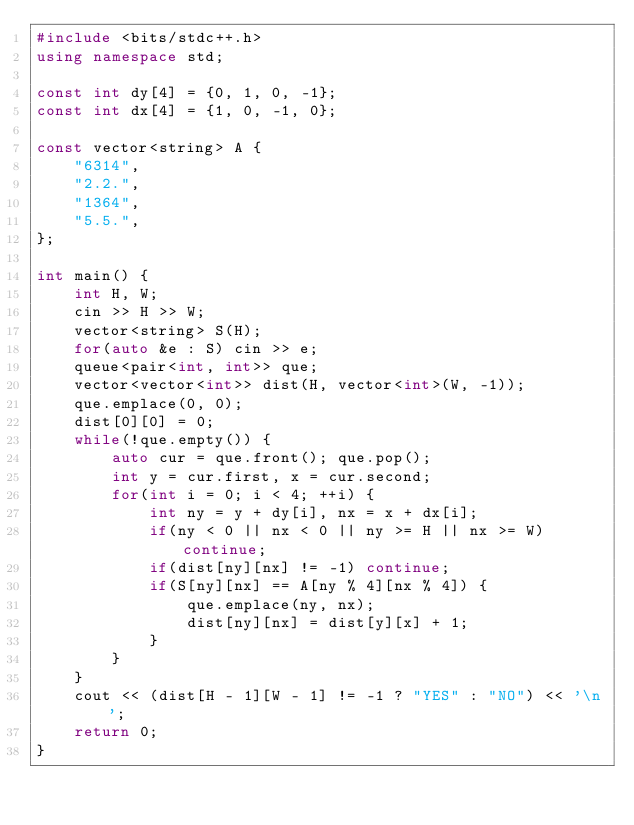<code> <loc_0><loc_0><loc_500><loc_500><_C++_>#include <bits/stdc++.h>
using namespace std;

const int dy[4] = {0, 1, 0, -1};
const int dx[4] = {1, 0, -1, 0};

const vector<string> A {
    "6314",
    "2.2.",
    "1364",
    "5.5.",
};

int main() {
    int H, W;
    cin >> H >> W;
    vector<string> S(H);
    for(auto &e : S) cin >> e;
    queue<pair<int, int>> que;
    vector<vector<int>> dist(H, vector<int>(W, -1));
    que.emplace(0, 0);
    dist[0][0] = 0;
    while(!que.empty()) {
        auto cur = que.front(); que.pop();
        int y = cur.first, x = cur.second;
        for(int i = 0; i < 4; ++i) {
            int ny = y + dy[i], nx = x + dx[i];
            if(ny < 0 || nx < 0 || ny >= H || nx >= W) continue;
            if(dist[ny][nx] != -1) continue;
            if(S[ny][nx] == A[ny % 4][nx % 4]) {
                que.emplace(ny, nx);
                dist[ny][nx] = dist[y][x] + 1;
            }
        }
    }
    cout << (dist[H - 1][W - 1] != -1 ? "YES" : "NO") << '\n';
    return 0;
}

</code> 